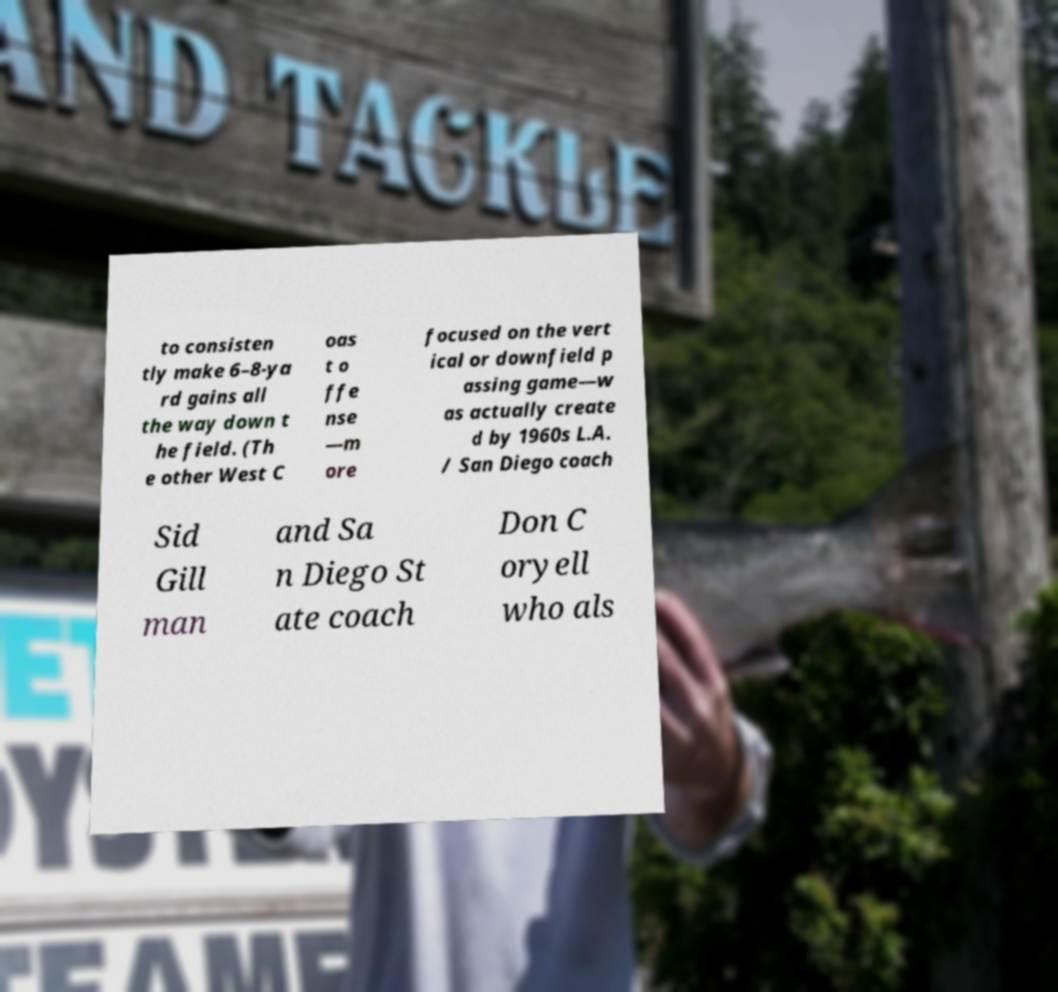There's text embedded in this image that I need extracted. Can you transcribe it verbatim? to consisten tly make 6–8-ya rd gains all the way down t he field. (Th e other West C oas t o ffe nse —m ore focused on the vert ical or downfield p assing game—w as actually create d by 1960s L.A. / San Diego coach Sid Gill man and Sa n Diego St ate coach Don C oryell who als 